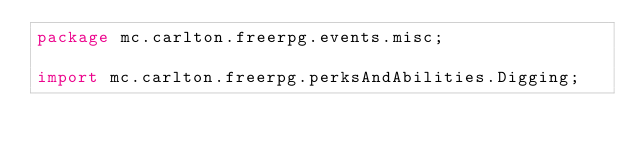<code> <loc_0><loc_0><loc_500><loc_500><_Java_>package mc.carlton.freerpg.events.misc;

import mc.carlton.freerpg.perksAndAbilities.Digging;</code> 